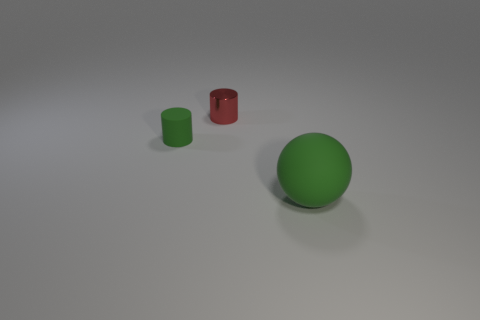How many blue objects are small rubber objects or tiny metallic things?
Your answer should be very brief. 0. There is a tiny thing that is the same material as the green ball; what is its color?
Your answer should be compact. Green. There is a large matte sphere; is its color the same as the rubber thing behind the large green rubber ball?
Offer a very short reply. Yes. The object that is both in front of the red object and on the left side of the ball is what color?
Keep it short and to the point. Green. How many rubber objects are right of the tiny matte object?
Give a very brief answer. 1. What number of things are green balls or green rubber things behind the large green object?
Your answer should be compact. 2. There is a green rubber object in front of the small green matte object; are there any large rubber things that are right of it?
Provide a succinct answer. No. There is a small cylinder left of the shiny thing; what is its color?
Give a very brief answer. Green. Are there an equal number of big objects to the right of the large green matte object and large green cubes?
Your answer should be very brief. Yes. What shape is the object that is in front of the red thing and left of the matte sphere?
Provide a short and direct response. Cylinder. 